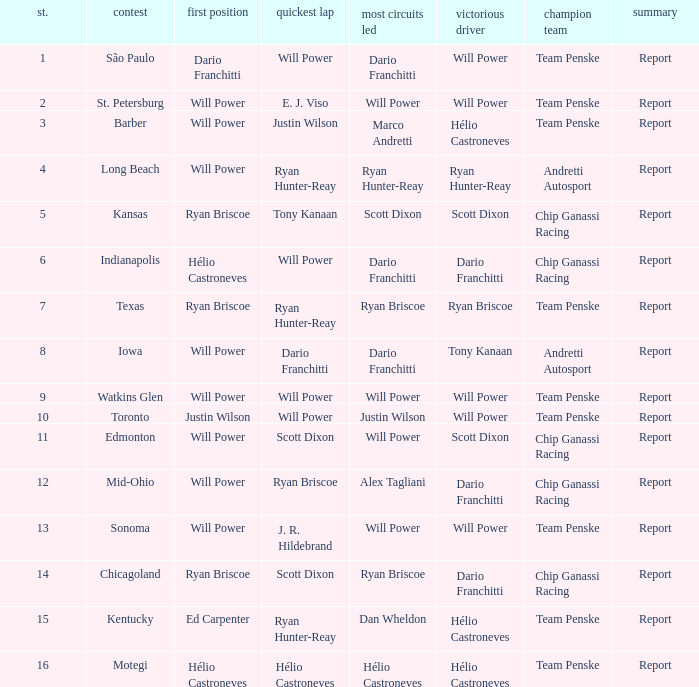What is the report for races where Will Power had both pole position and fastest lap? Report. Help me parse the entirety of this table. {'header': ['st.', 'contest', 'first position', 'quickest lap', 'most circuits led', 'victorious driver', 'champion team', 'summary'], 'rows': [['1', 'São Paulo', 'Dario Franchitti', 'Will Power', 'Dario Franchitti', 'Will Power', 'Team Penske', 'Report'], ['2', 'St. Petersburg', 'Will Power', 'E. J. Viso', 'Will Power', 'Will Power', 'Team Penske', 'Report'], ['3', 'Barber', 'Will Power', 'Justin Wilson', 'Marco Andretti', 'Hélio Castroneves', 'Team Penske', 'Report'], ['4', 'Long Beach', 'Will Power', 'Ryan Hunter-Reay', 'Ryan Hunter-Reay', 'Ryan Hunter-Reay', 'Andretti Autosport', 'Report'], ['5', 'Kansas', 'Ryan Briscoe', 'Tony Kanaan', 'Scott Dixon', 'Scott Dixon', 'Chip Ganassi Racing', 'Report'], ['6', 'Indianapolis', 'Hélio Castroneves', 'Will Power', 'Dario Franchitti', 'Dario Franchitti', 'Chip Ganassi Racing', 'Report'], ['7', 'Texas', 'Ryan Briscoe', 'Ryan Hunter-Reay', 'Ryan Briscoe', 'Ryan Briscoe', 'Team Penske', 'Report'], ['8', 'Iowa', 'Will Power', 'Dario Franchitti', 'Dario Franchitti', 'Tony Kanaan', 'Andretti Autosport', 'Report'], ['9', 'Watkins Glen', 'Will Power', 'Will Power', 'Will Power', 'Will Power', 'Team Penske', 'Report'], ['10', 'Toronto', 'Justin Wilson', 'Will Power', 'Justin Wilson', 'Will Power', 'Team Penske', 'Report'], ['11', 'Edmonton', 'Will Power', 'Scott Dixon', 'Will Power', 'Scott Dixon', 'Chip Ganassi Racing', 'Report'], ['12', 'Mid-Ohio', 'Will Power', 'Ryan Briscoe', 'Alex Tagliani', 'Dario Franchitti', 'Chip Ganassi Racing', 'Report'], ['13', 'Sonoma', 'Will Power', 'J. R. Hildebrand', 'Will Power', 'Will Power', 'Team Penske', 'Report'], ['14', 'Chicagoland', 'Ryan Briscoe', 'Scott Dixon', 'Ryan Briscoe', 'Dario Franchitti', 'Chip Ganassi Racing', 'Report'], ['15', 'Kentucky', 'Ed Carpenter', 'Ryan Hunter-Reay', 'Dan Wheldon', 'Hélio Castroneves', 'Team Penske', 'Report'], ['16', 'Motegi', 'Hélio Castroneves', 'Hélio Castroneves', 'Hélio Castroneves', 'Hélio Castroneves', 'Team Penske', 'Report']]} 